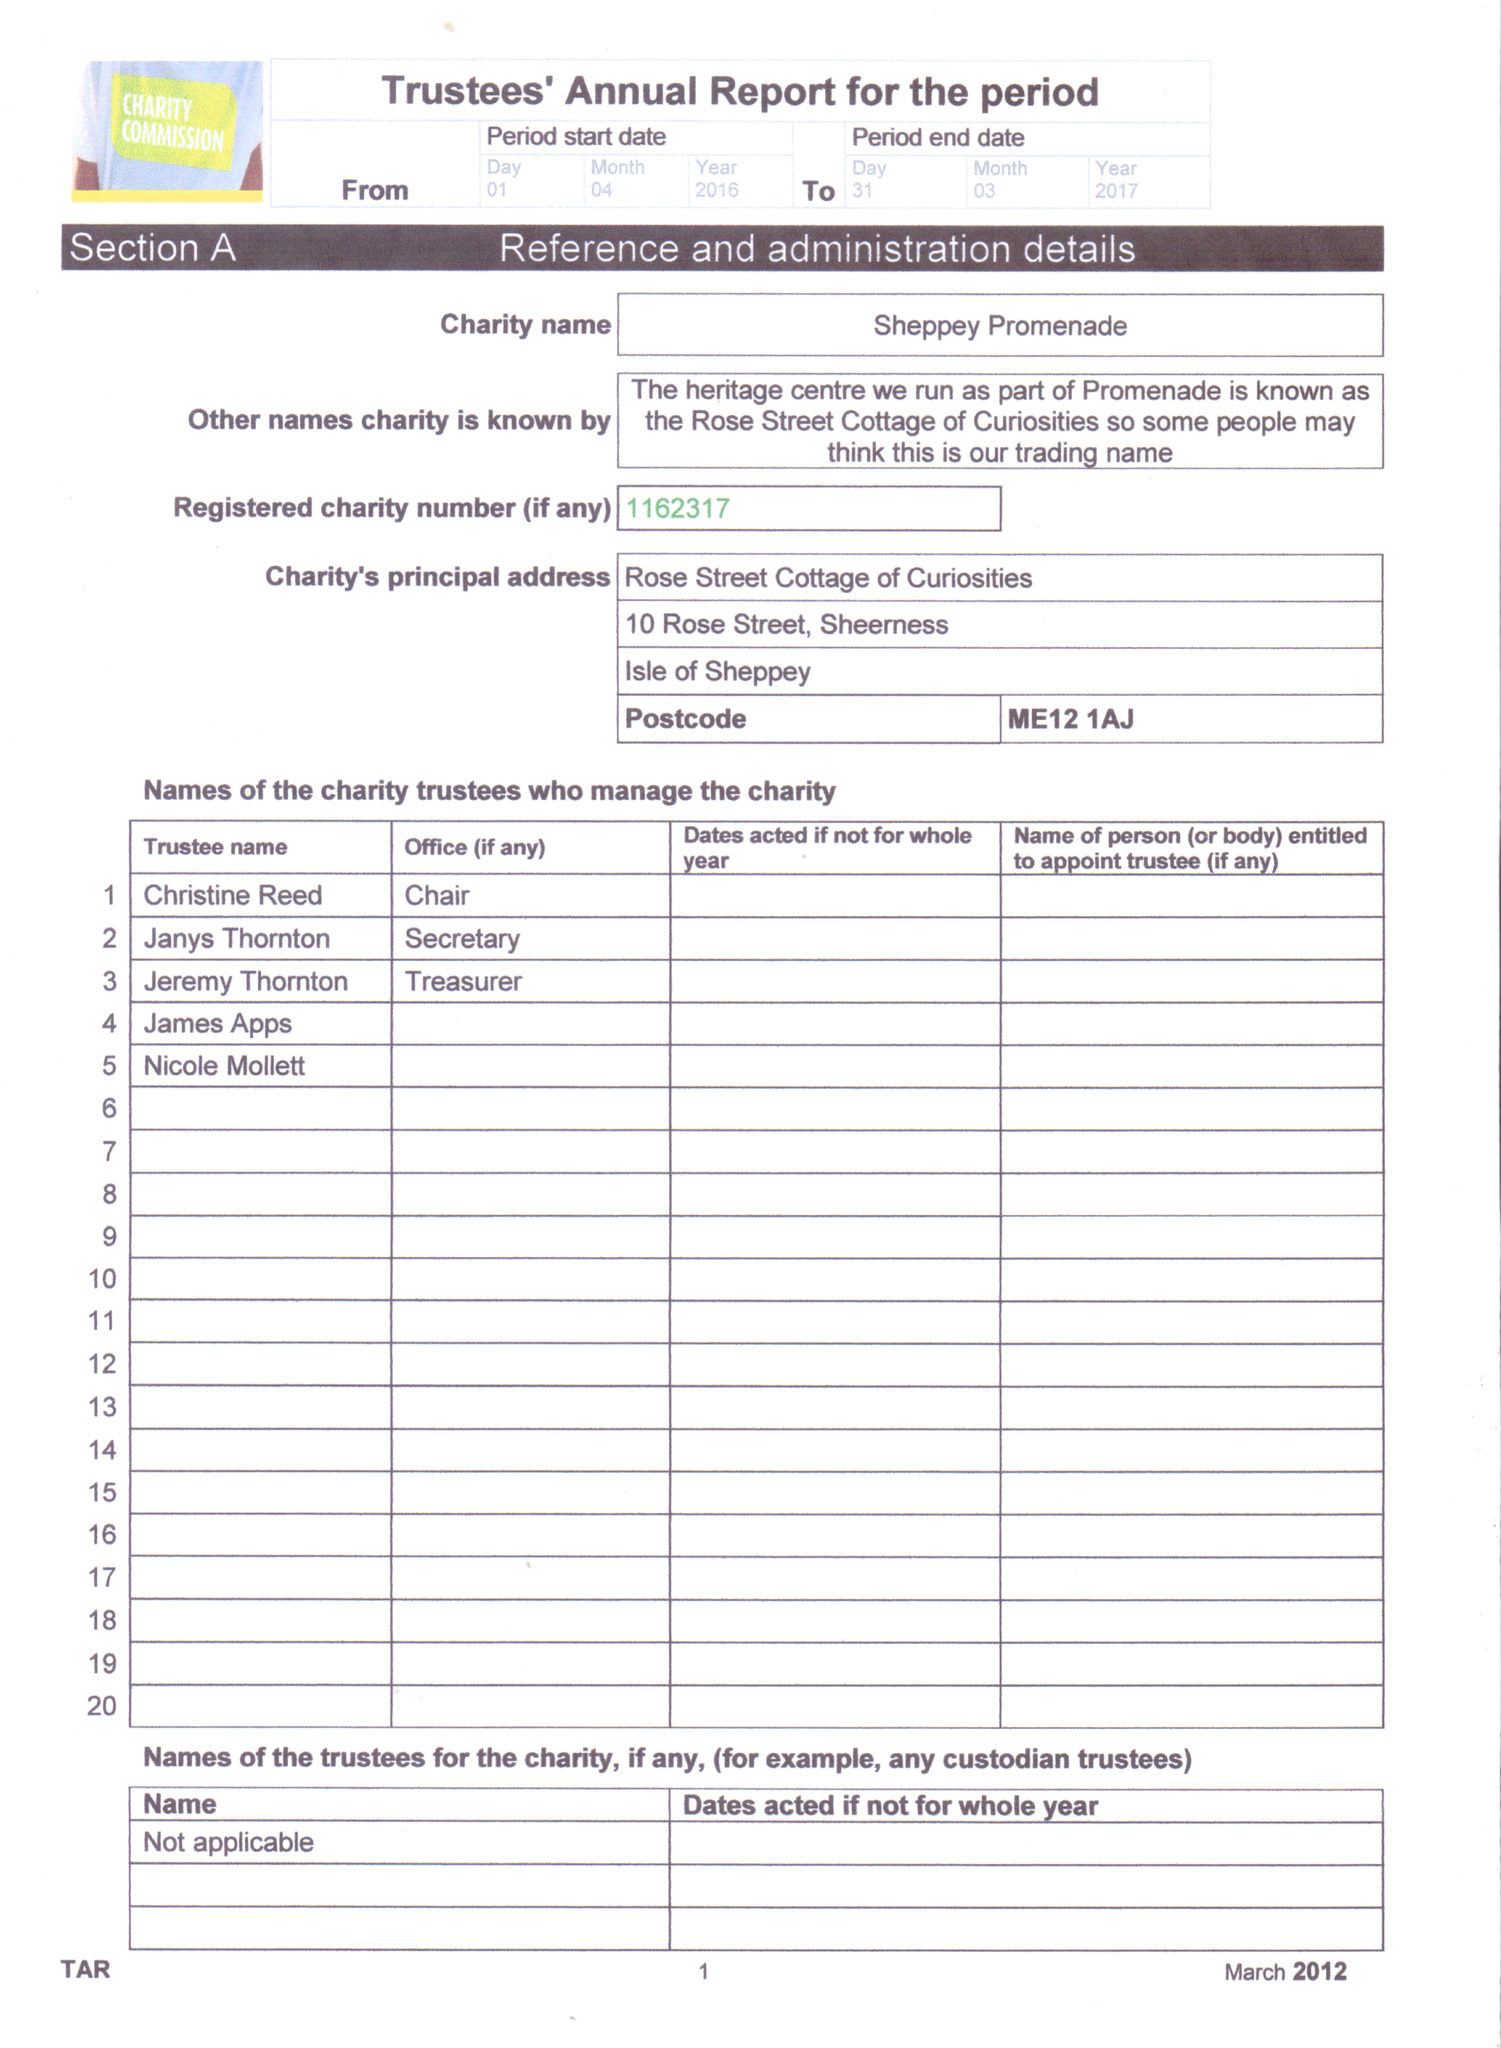What is the value for the address__street_line?
Answer the question using a single word or phrase. 10 ROSE STREET 